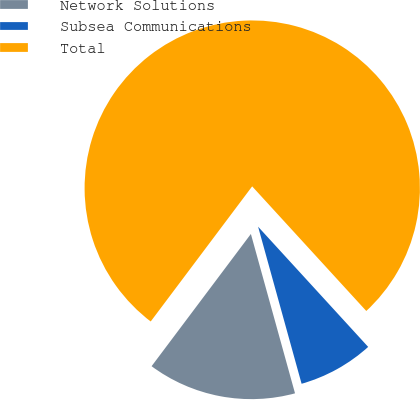<chart> <loc_0><loc_0><loc_500><loc_500><pie_chart><fcel>Network Solutions<fcel>Subsea Communications<fcel>Total<nl><fcel>14.55%<fcel>7.5%<fcel>77.95%<nl></chart> 